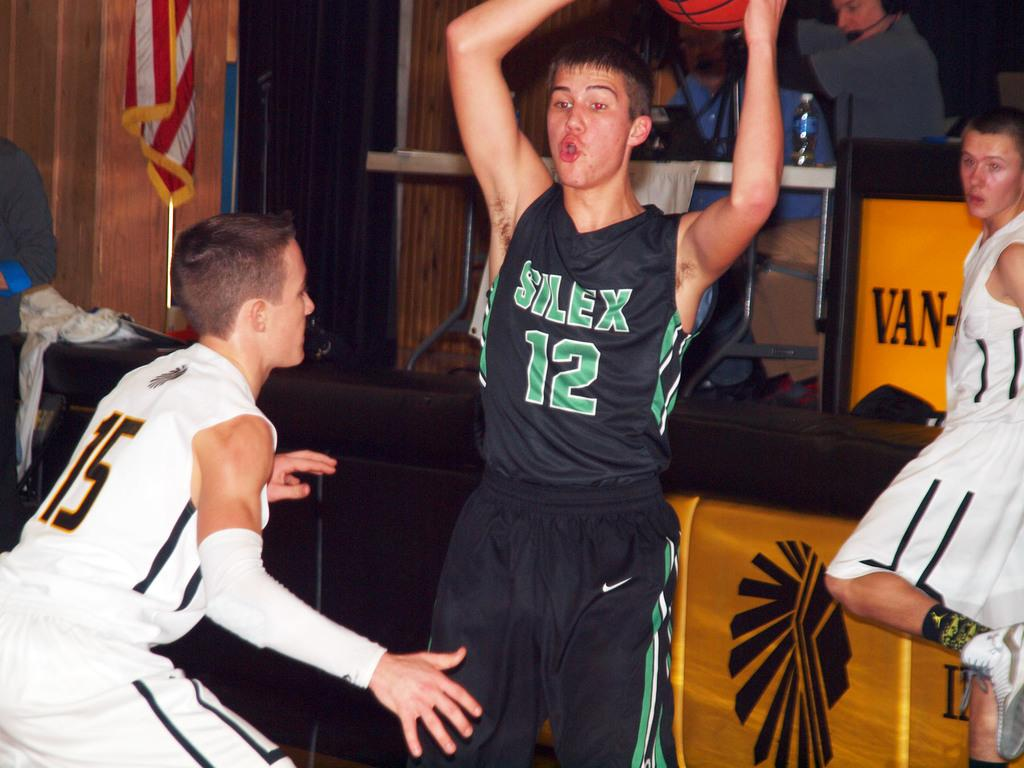<image>
Create a compact narrative representing the image presented. Player number 12 holds the basketball over his head to keep it away from number 15. 